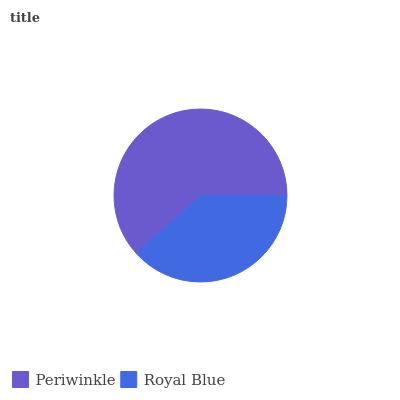Is Royal Blue the minimum?
Answer yes or no. Yes. Is Periwinkle the maximum?
Answer yes or no. Yes. Is Royal Blue the maximum?
Answer yes or no. No. Is Periwinkle greater than Royal Blue?
Answer yes or no. Yes. Is Royal Blue less than Periwinkle?
Answer yes or no. Yes. Is Royal Blue greater than Periwinkle?
Answer yes or no. No. Is Periwinkle less than Royal Blue?
Answer yes or no. No. Is Periwinkle the high median?
Answer yes or no. Yes. Is Royal Blue the low median?
Answer yes or no. Yes. Is Royal Blue the high median?
Answer yes or no. No. Is Periwinkle the low median?
Answer yes or no. No. 